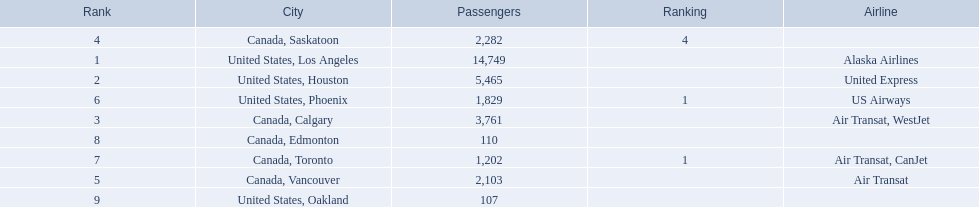Which cities had less than 2,000 passengers? United States, Phoenix, Canada, Toronto, Canada, Edmonton, United States, Oakland. Of these cities, which had fewer than 1,000 passengers? Canada, Edmonton, United States, Oakland. Of the cities in the previous answer, which one had only 107 passengers? United States, Oakland. 